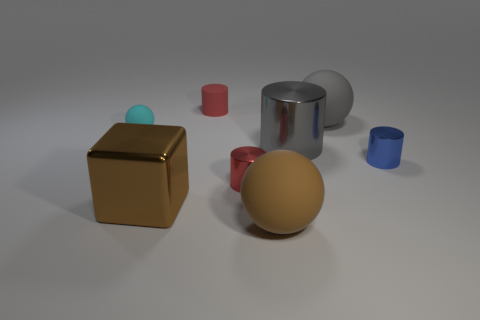Add 1 metallic cylinders. How many objects exist? 9 Subtract all cubes. How many objects are left? 7 Add 2 large gray balls. How many large gray balls exist? 3 Subtract 0 green cylinders. How many objects are left? 8 Subtract all gray rubber objects. Subtract all gray balls. How many objects are left? 6 Add 6 large gray things. How many large gray things are left? 8 